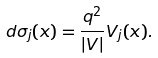<formula> <loc_0><loc_0><loc_500><loc_500>d \sigma _ { j } ( x ) = \frac { q ^ { 2 } } { | V | } V _ { j } ( x ) .</formula> 